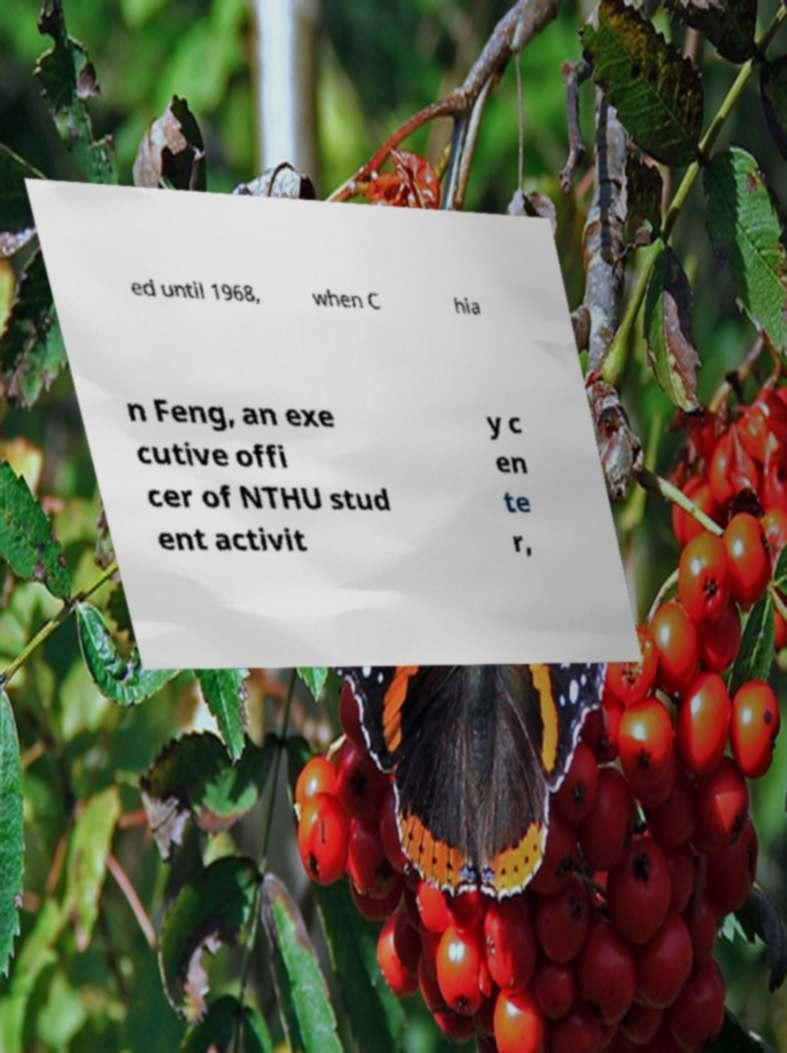For documentation purposes, I need the text within this image transcribed. Could you provide that? ed until 1968, when C hia n Feng, an exe cutive offi cer of NTHU stud ent activit y c en te r, 